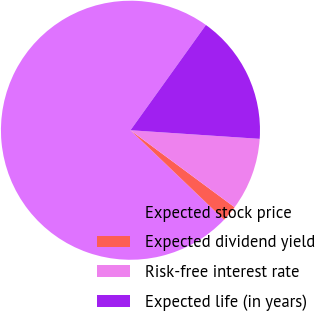Convert chart. <chart><loc_0><loc_0><loc_500><loc_500><pie_chart><fcel>Expected stock price<fcel>Expected dividend yield<fcel>Risk-free interest rate<fcel>Expected life (in years)<nl><fcel>72.75%<fcel>2.01%<fcel>9.08%<fcel>16.16%<nl></chart> 